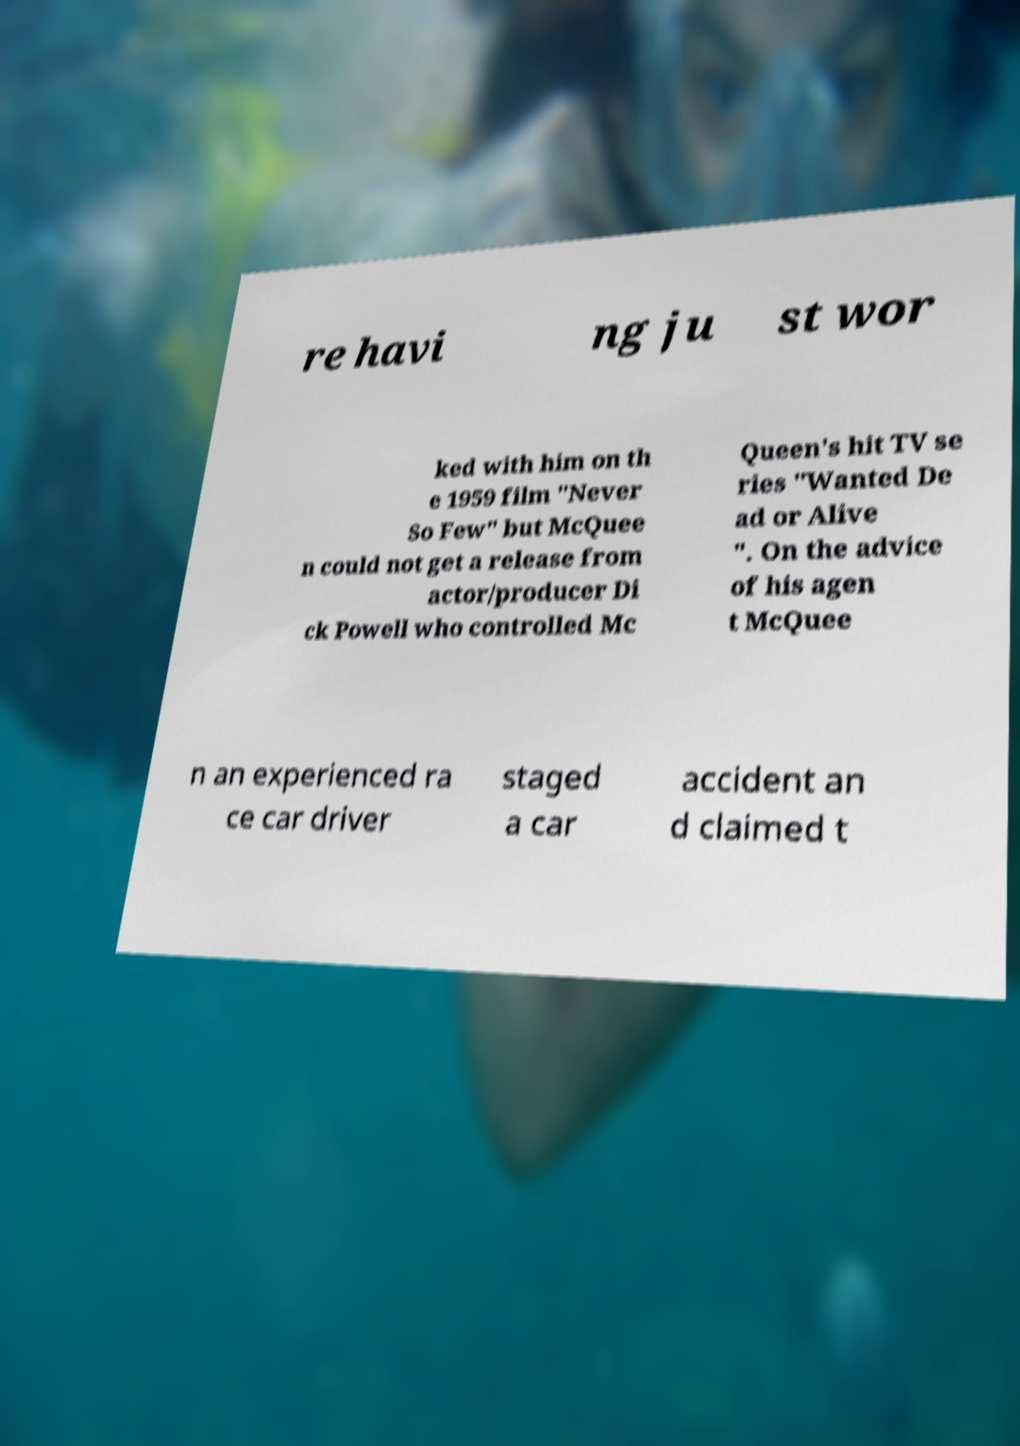Can you accurately transcribe the text from the provided image for me? re havi ng ju st wor ked with him on th e 1959 film "Never So Few" but McQuee n could not get a release from actor/producer Di ck Powell who controlled Mc Queen's hit TV se ries "Wanted De ad or Alive ". On the advice of his agen t McQuee n an experienced ra ce car driver staged a car accident an d claimed t 